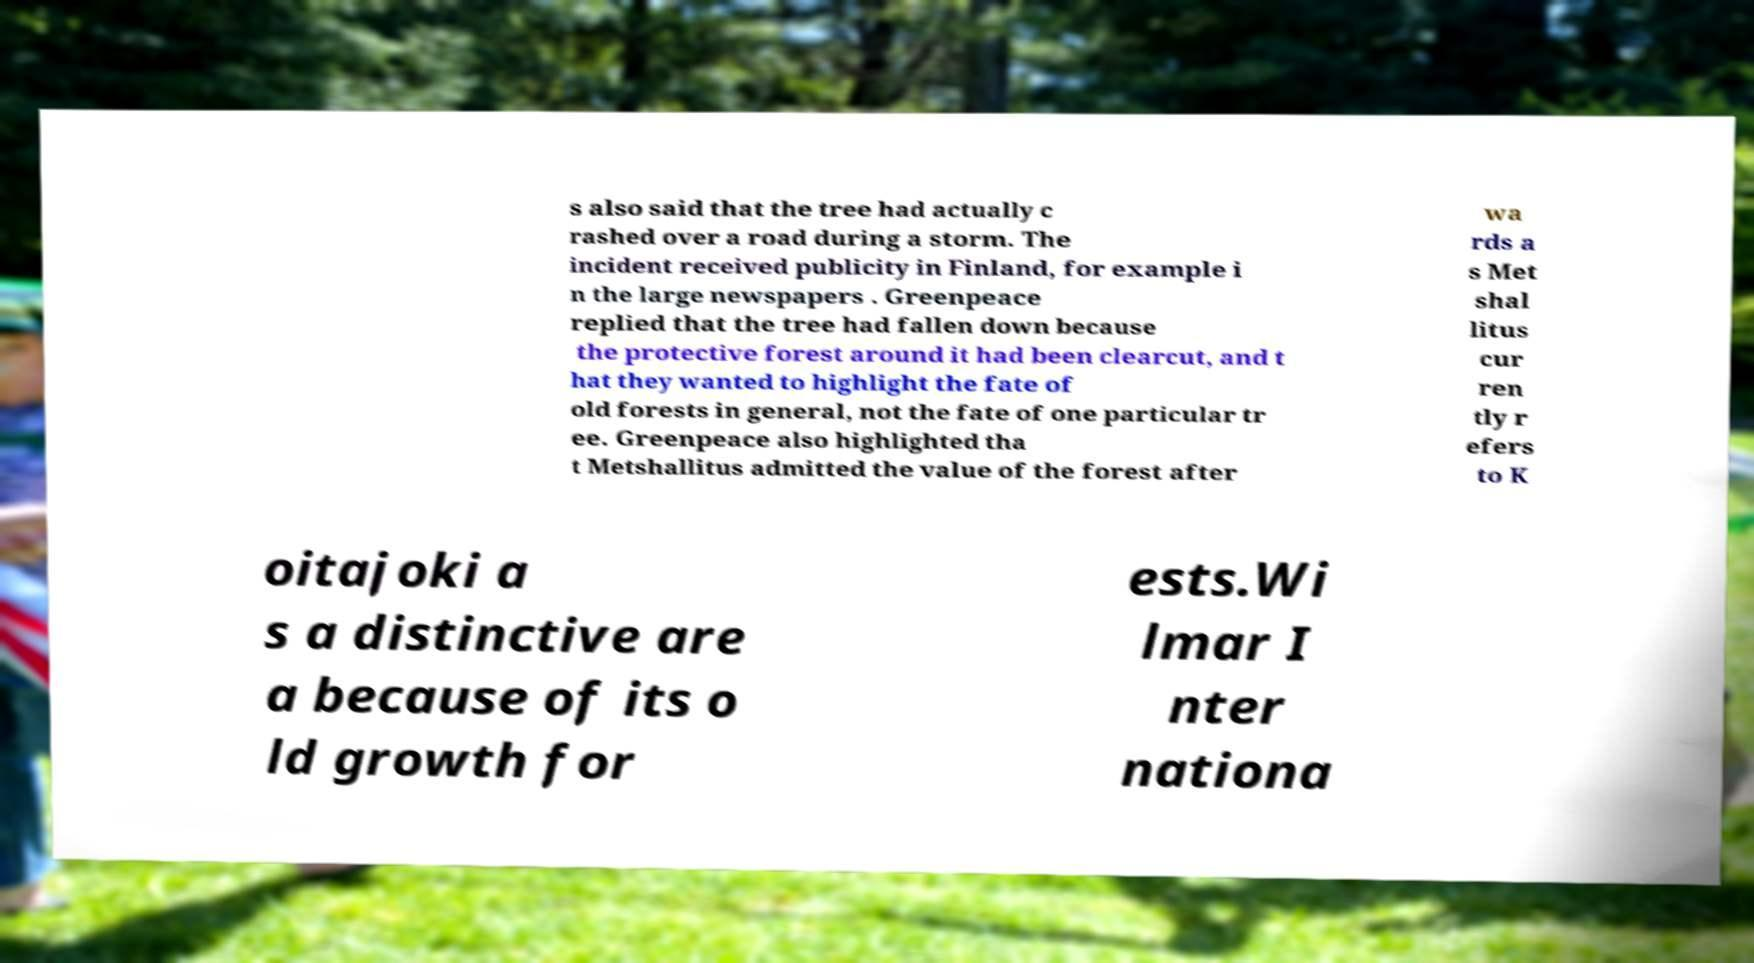Could you extract and type out the text from this image? s also said that the tree had actually c rashed over a road during a storm. The incident received publicity in Finland, for example i n the large newspapers . Greenpeace replied that the tree had fallen down because the protective forest around it had been clearcut, and t hat they wanted to highlight the fate of old forests in general, not the fate of one particular tr ee. Greenpeace also highlighted tha t Metshallitus admitted the value of the forest after wa rds a s Met shal litus cur ren tly r efers to K oitajoki a s a distinctive are a because of its o ld growth for ests.Wi lmar I nter nationa 